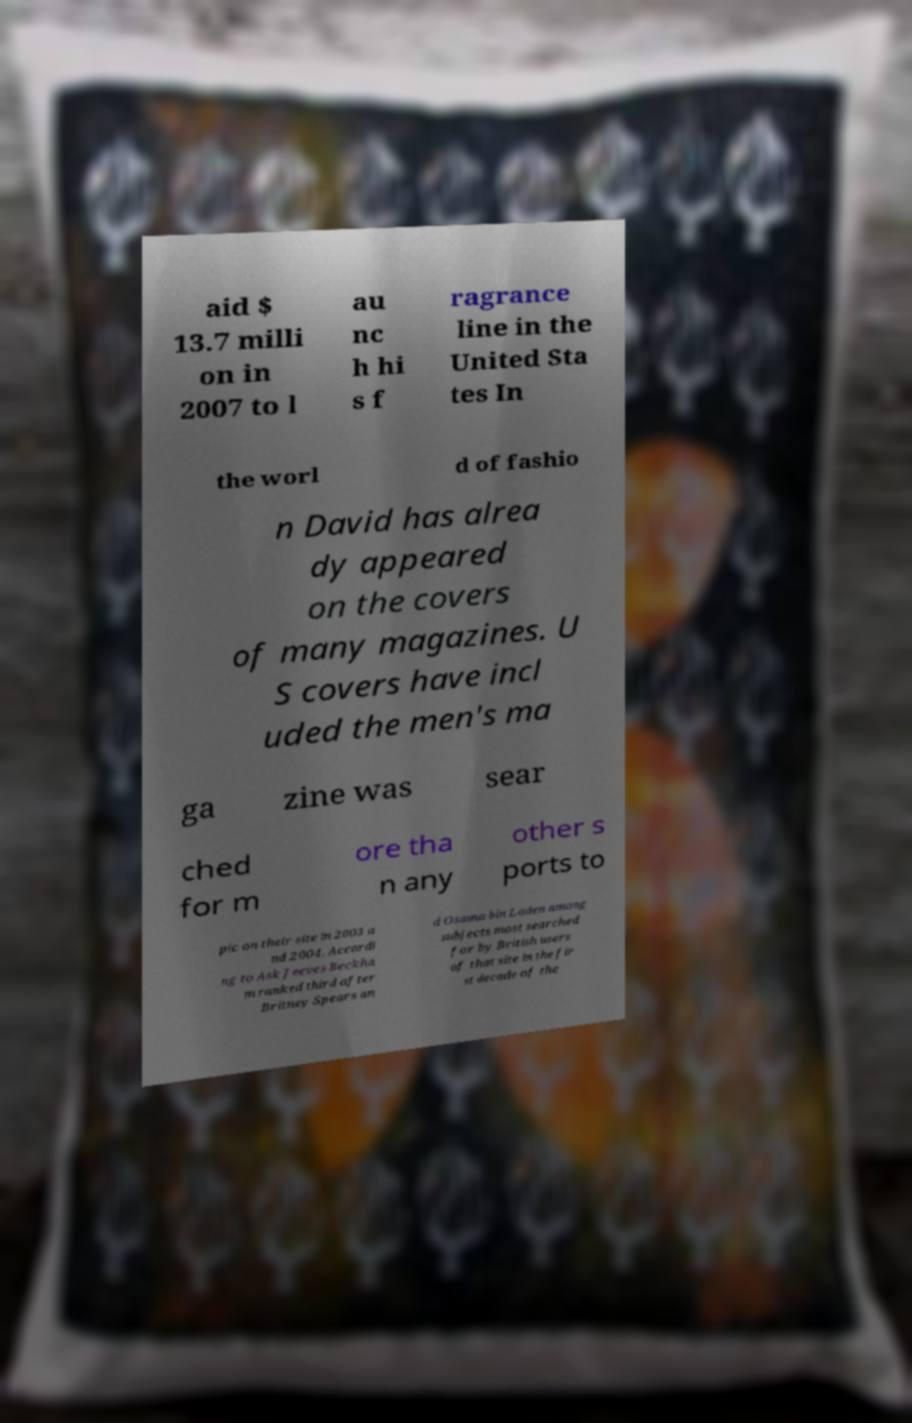I need the written content from this picture converted into text. Can you do that? aid $ 13.7 milli on in 2007 to l au nc h hi s f ragrance line in the United Sta tes In the worl d of fashio n David has alrea dy appeared on the covers of many magazines. U S covers have incl uded the men's ma ga zine was sear ched for m ore tha n any other s ports to pic on their site in 2003 a nd 2004. Accordi ng to Ask Jeeves Beckha m ranked third after Britney Spears an d Osama bin Laden among subjects most searched for by British users of that site in the fir st decade of the 